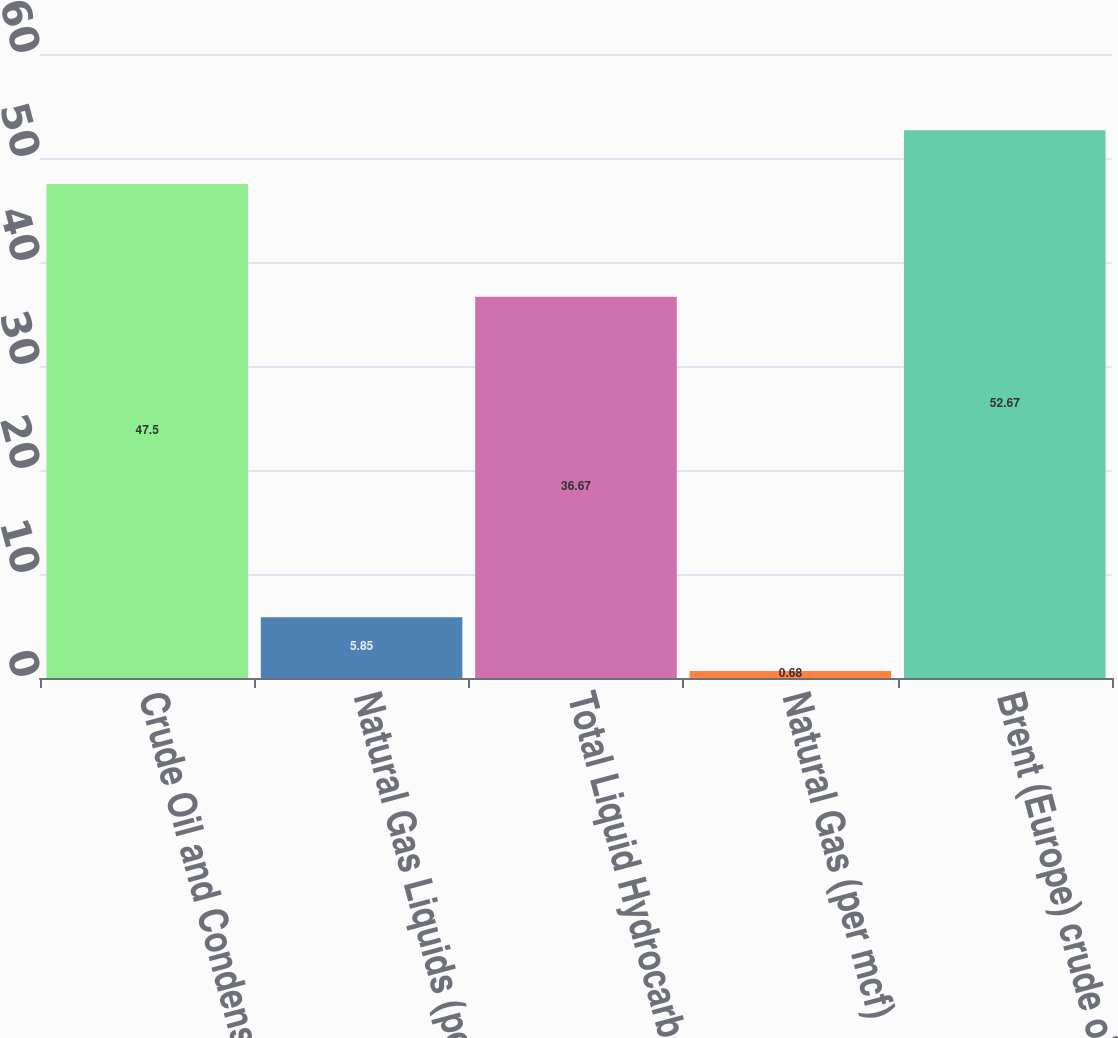Convert chart to OTSL. <chart><loc_0><loc_0><loc_500><loc_500><bar_chart><fcel>Crude Oil and Condensate (per<fcel>Natural Gas Liquids (per bbl)<fcel>Total Liquid Hydrocarbons (per<fcel>Natural Gas (per mcf)<fcel>Brent (Europe) crude oil (per<nl><fcel>47.5<fcel>5.85<fcel>36.67<fcel>0.68<fcel>52.67<nl></chart> 